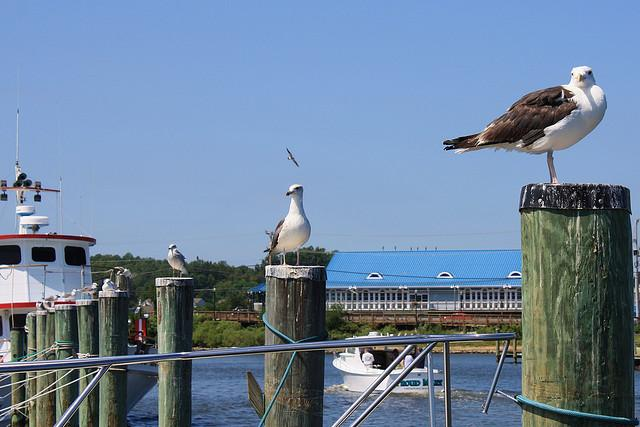What vessels are tied to the piers here? Please explain your reasoning. boats. There are boats at the pier. 